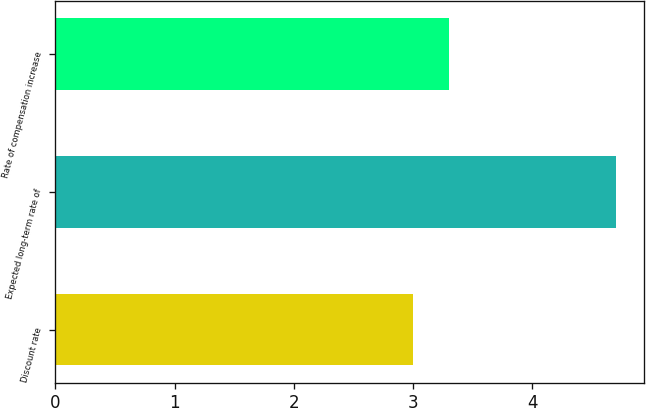Convert chart. <chart><loc_0><loc_0><loc_500><loc_500><bar_chart><fcel>Discount rate<fcel>Expected long-term rate of<fcel>Rate of compensation increase<nl><fcel>3<fcel>4.7<fcel>3.3<nl></chart> 